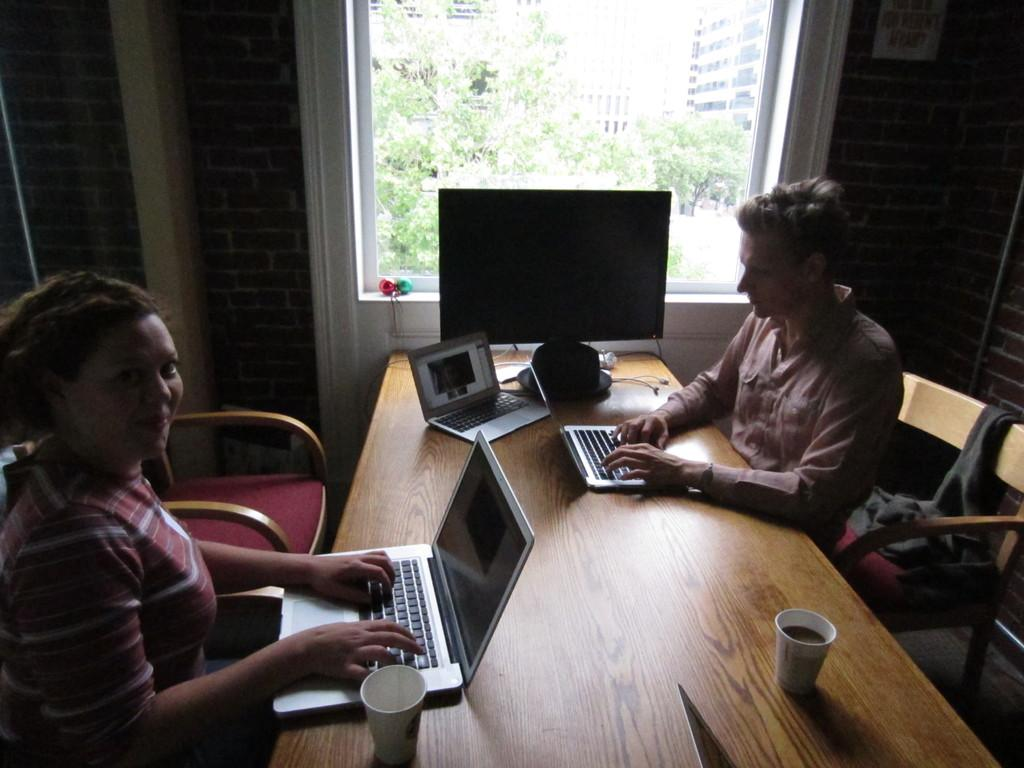How many people are sitting on the chair in the image? There are two persons sitting on a chair in the image. What can be seen on the table in the room? There is a monitor and laptops on the table in the image. What is visible outside the window in the room? Buildings and trees are visible outside the window in the room. What type of jelly can be seen on the laptops in the image? There is no jelly present on the laptops in the image. What is the air quality like in the room based on the image? The image does not provide any information about the air quality in the room. 